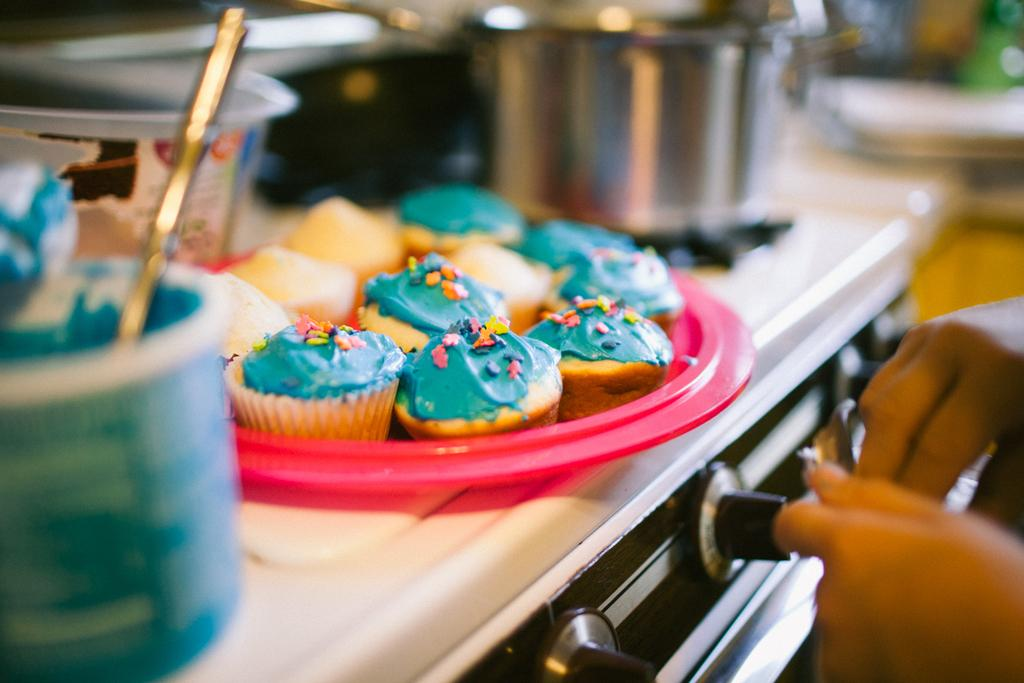What type of food is visible in the image? There are cupcakes in the image. What else can be seen in the image besides the cupcakes? There are bowls and other things on the stove in the image. Can you describe the presence of human hands in the image? Human hands are visible on the right-hand side of the image. How many children are playing in the rainstorm depicted in the image? There is no rainstorm or children present in the image. What type of cough is the person experiencing in the image? There is no person or cough present in the image. 